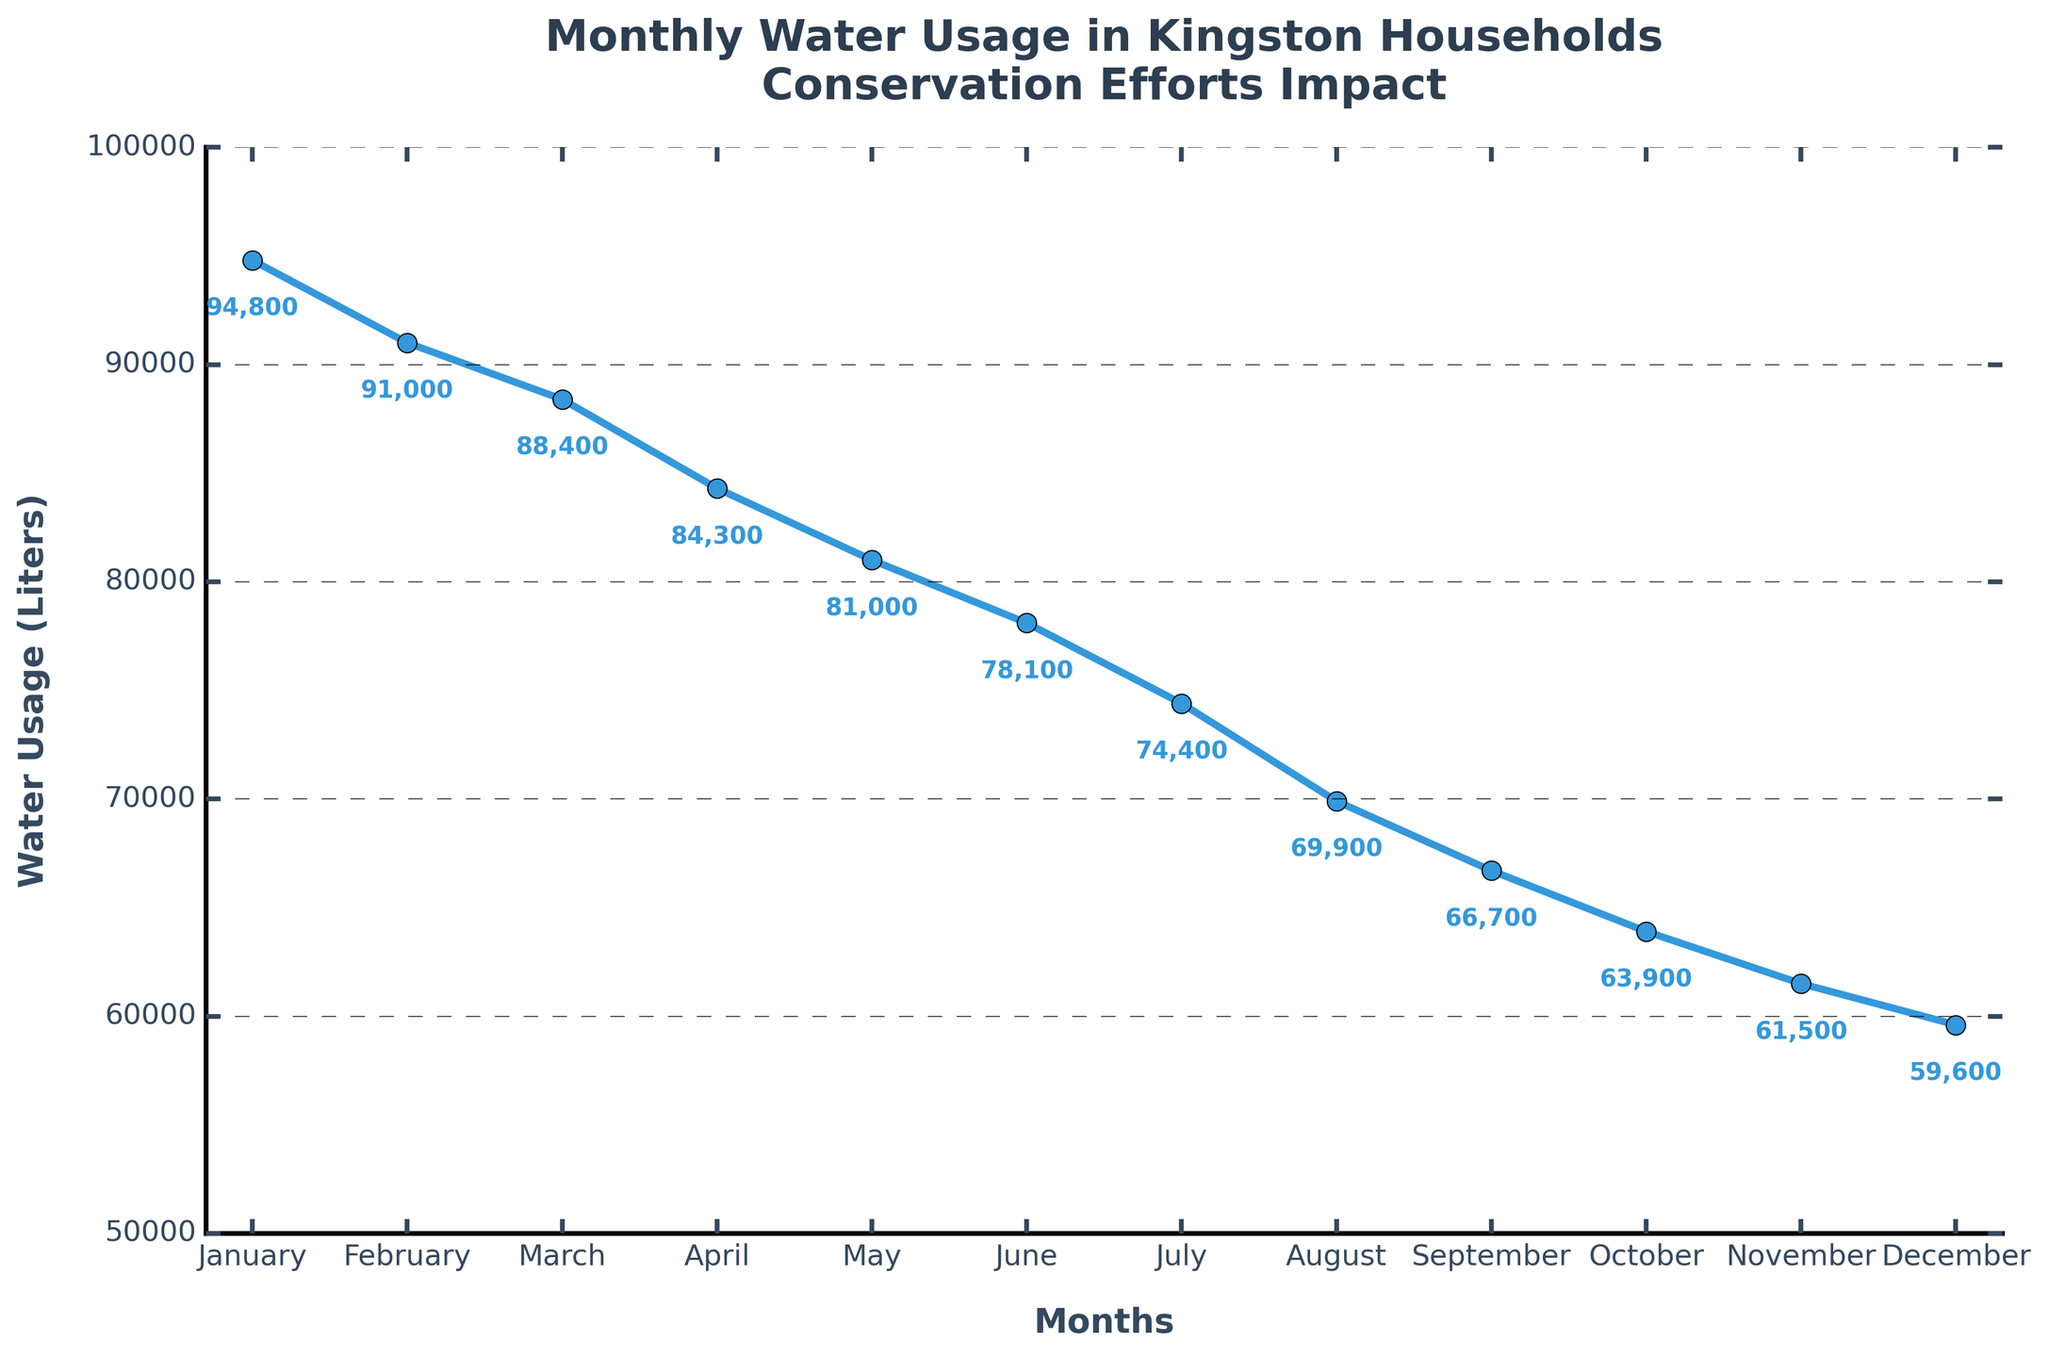What's the title of the chart? The title is prominently displayed at the top of the figure, summarizing its main purpose. The title is "Monthly Water Usage in Kingston Households Conservation Efforts Impact".
Answer: Monthly Water Usage in Kingston Households Conservation Efforts Impact Which month had the largest decrease in water usage? Identify the month with the bar having the greatest negative value. In August, water usage decreased the most with a change of -4500 liters.
Answer: August What is the cumulative water usage at the end of the year? Look at the cumulative value for December, which is the final point in the cumulative line. The cumulative water usage in December is 59,600 liters.
Answer: 59,600 liters How much did water usage decrease between January and December? Subtract the cumulative usage in December from that in January. The cumulative usage in January is 94,800 liters, and in December, it is 59,600 liters. So, 94,800 - 59,600 = 35,200 liters.
Answer: 35,200 liters By how much did water usage decrease in the first quarter of the year? Sum the changes for January, February, and March: -5200 + -3800 + -2600 = -11,600 liters.
Answer: 11,600 liters Which month had the smallest decrease in water usage? Identify the month with the bar having the smallest negative value. December had the smallest decrease with a change of -1900 liters.
Answer: December Compare the water usage decrease in May and October. Which had a greater reduction? Look at the changes for May and October. May had a change of -3300 liters and October had a change of -2800 liters. Therefore, May had a greater reduction.
Answer: May What was the cumulative water usage after the first half of the year (end of June)? Check the cumulative value for June. The cumulative water usage in June is 78,100 liters.
Answer: 78,100 liters Calculate the average monthly decrease in water usage for the entire year. Sum up all the monthly changes and divide by 12. Sum of changes = -5200 + -3800 + -2600 + -4100 + -3300 + -2900 + -3700 + -4500 + -3200 + -2800 + -2400 + -1900 = -40,400 liters. Average monthly decrease = -40,400 / 12 ≈ -3367 liters.
Answer: -3367 liters How did the conservation efforts impact water usage cumulatively by September? Check the cumulative value for September. The cumulative water usage by September is 66,700 liters. This can be visually traced on the cumulative line.
Answer: 66,700 liters 